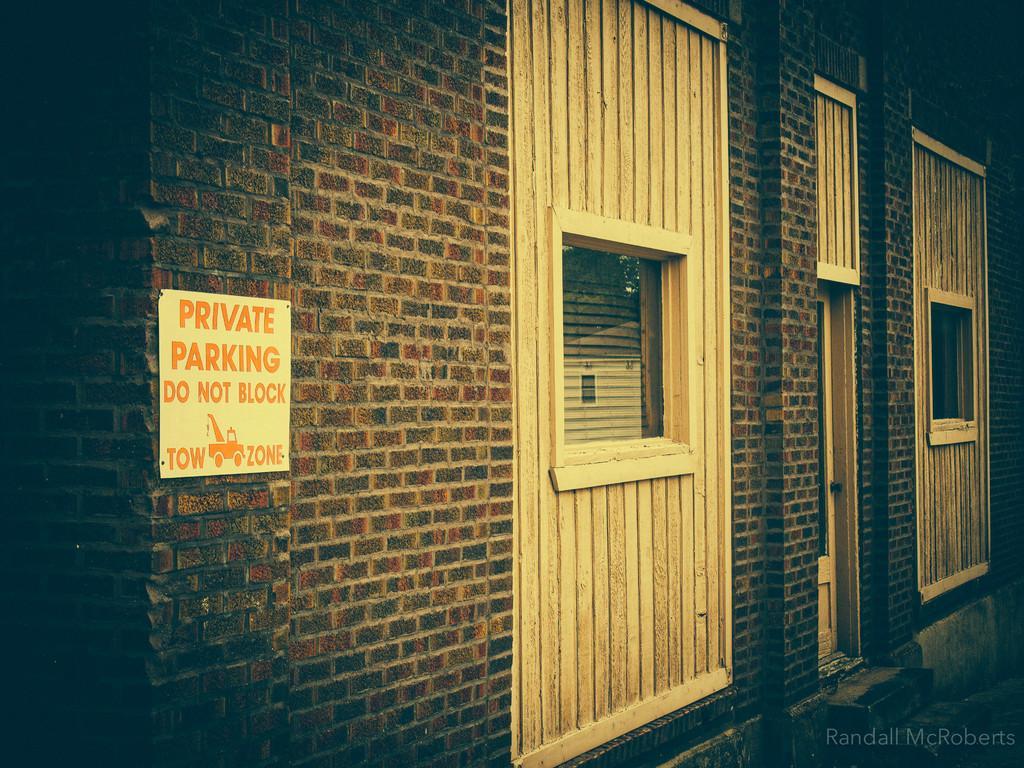Describe this image in one or two sentences. In this image we can see a building with windows, door and a board pinned to a wall. 